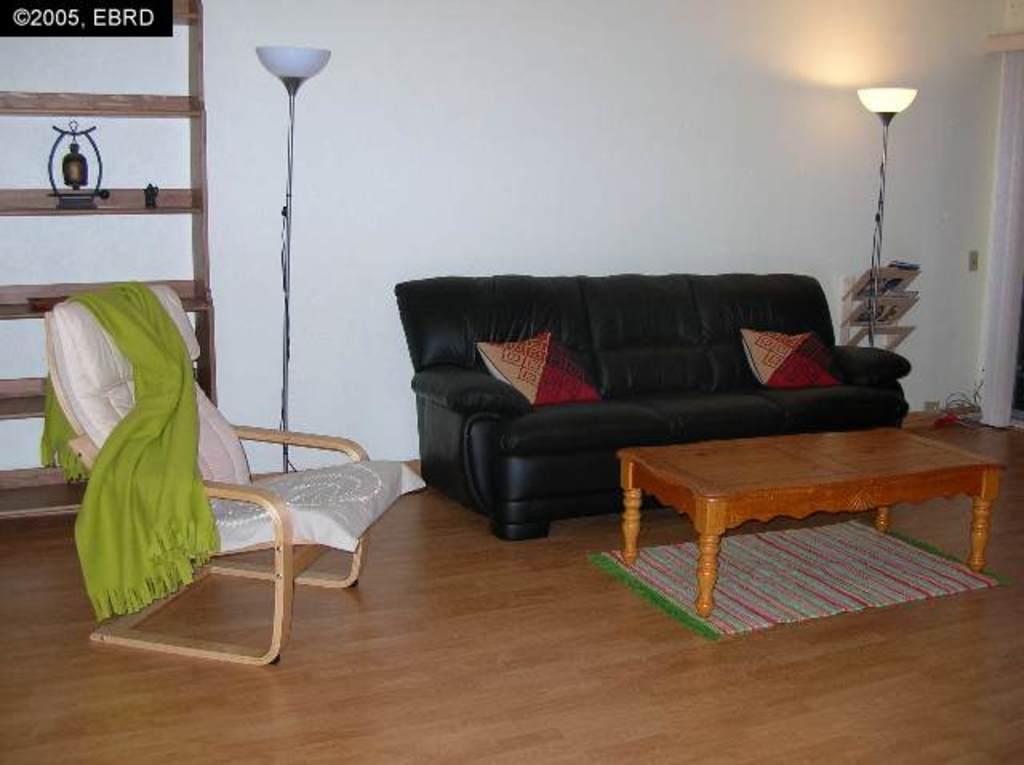Can you describe this image briefly? In this image there is a sofa. Colourful two cushions on it. In front there is a table under which a mat is placed. On two sides of sofa a lamp is placed. At left side there is a wooden rack in which an antique item is placed. At left side there is a chair on which cloth is placed. 